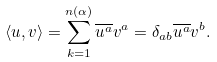<formula> <loc_0><loc_0><loc_500><loc_500>\langle u , v \rangle = \sum _ { k = 1 } ^ { n ( \alpha ) } \overline { u ^ { a } } v ^ { a } = \delta _ { a b } \overline { u ^ { a } } v ^ { b } .</formula> 